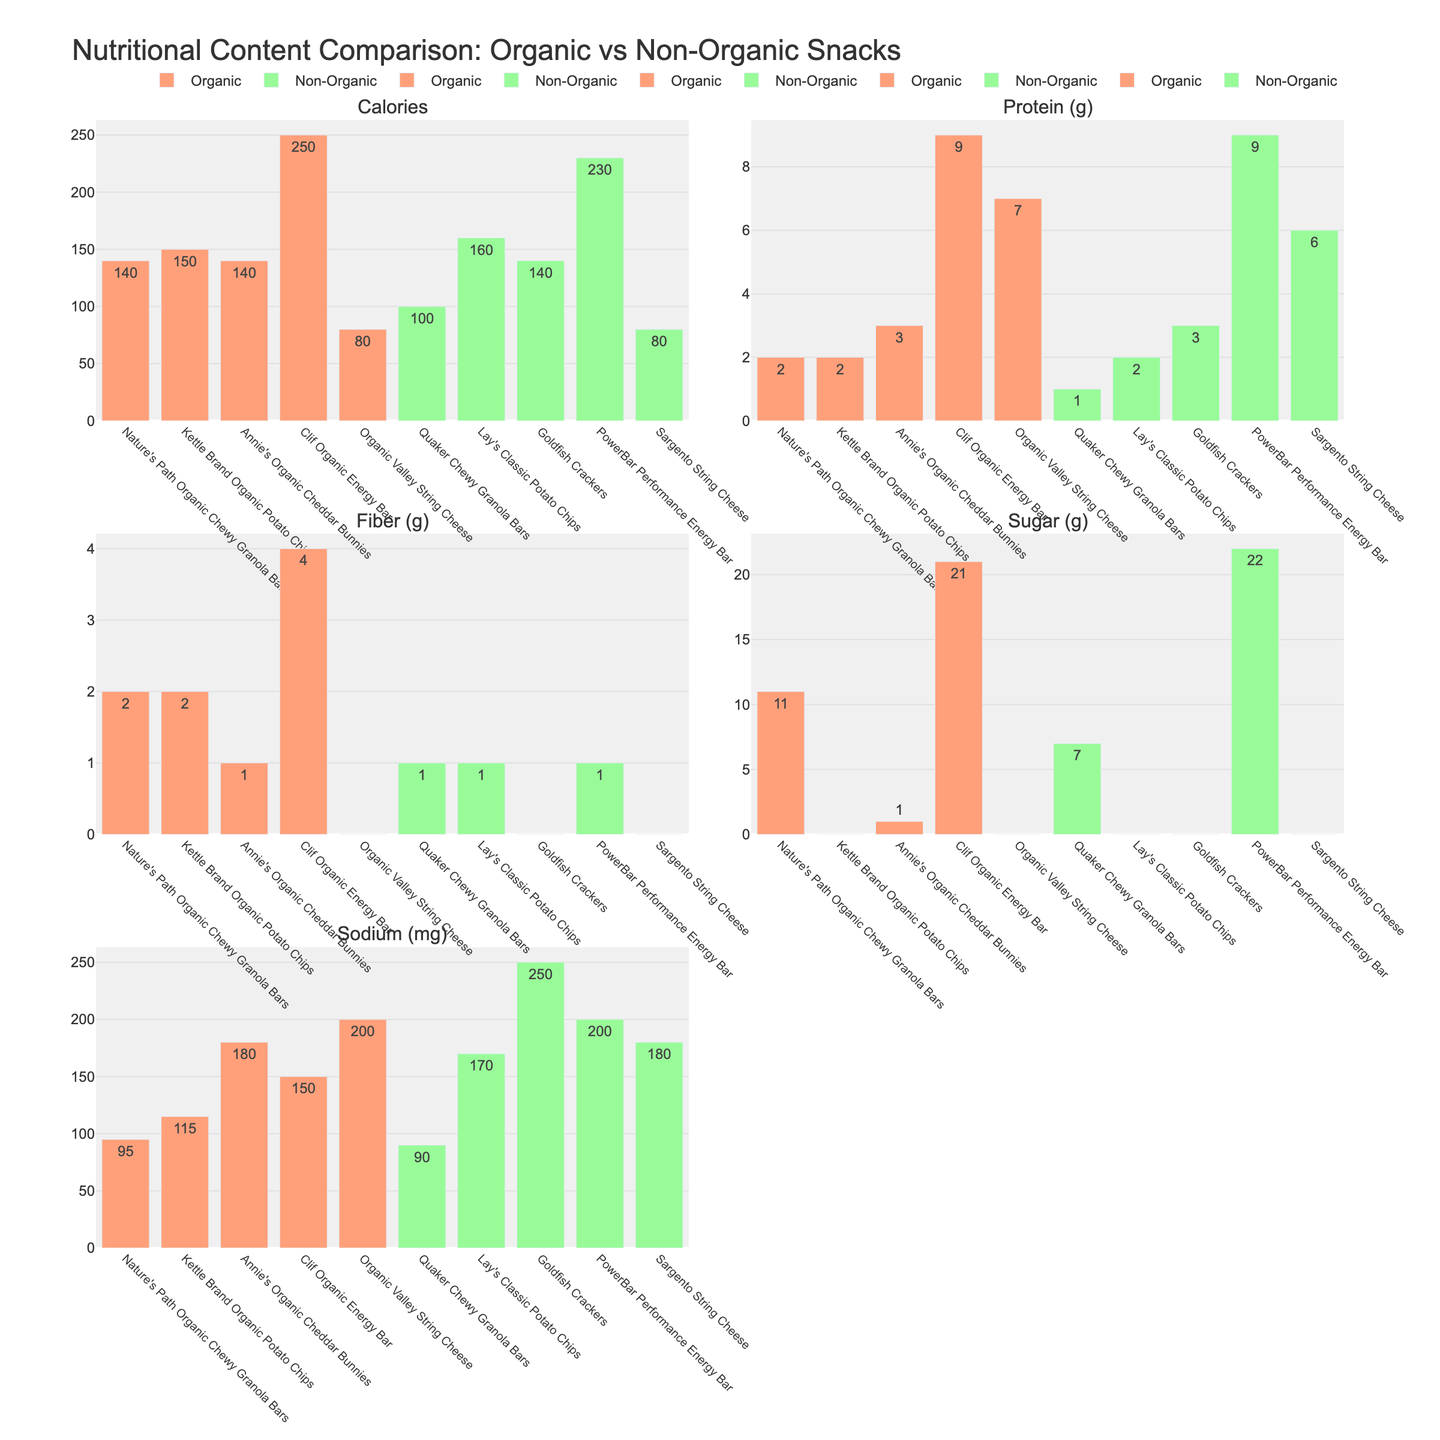what is the title of the figure? The title is usually present at the top of the figure in larger and bolder font compared to the rest of the text. In this case, it says "Nutritional Content Comparison: Organic vs Non-Organic Snacks"
Answer: Nutritional Content Comparison: Organic vs Non-Organic Snacks how many subplots are in the figure? The figure is divided into separate sections, each with its own title. Here, there are 5 subplot titles: "Calories", "Protein (g)", "Fiber (g)", "Sugar (g)", and "Sodium (mg)"
Answer: 5 which organic snack has the highest calorie content? Locate the subplot with the title "Calories" and compare the heights of the bars representing organic snacks. The tallest bar corresponds to "Clif Organic Energy Bar" with 250 calories
Answer: Clif Organic Energy Bar what is the total protein content of Lay's Classic Potato Chips and Sargento String Cheese? Find the subplot with "Protein (g)" and look for the values of "Lay's Classic Potato Chips" (2g) and "Sargento String Cheese" (6g). Add them together: 2 + 6 = 8
Answer: 8g which non-organic snack has the least sugar content? In the "Sugar (g)" subplot, look at the bars for non-organic snacks. The "Lay's Classic Potato Chips" and "Goldfish Crackers" both have 0 grams of sugar, which is the least
Answer: Lay's Classic Potato Chips and Goldfish Crackers is there a snack that has the same sodium content regardless of being organic or non-organic? Compare the heights of the bars for both organic and non-organic snacks in the "Sodium (mg)" subplot. Both "Organic Valley String Cheese" and "Sargento String Cheese" are at 200 mg, which matches for both types
Answer: Organic Valley String Cheese and Sargento String Cheese which type, organic or non-organic, tends to have higher sugar content on average? Review the "Sugar (g)" subplot, and calculate the average sugar content for both organic and non-organic snacks. For organic: (11 + 0 + 1 + 21 + 0)/5 = 6.6. For non-organic: (7 + 0 + 0 + 22 + 0)/5 = 5.8. This shows organic has a higher average
Answer: Organic 